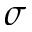<formula> <loc_0><loc_0><loc_500><loc_500>\sigma</formula> 